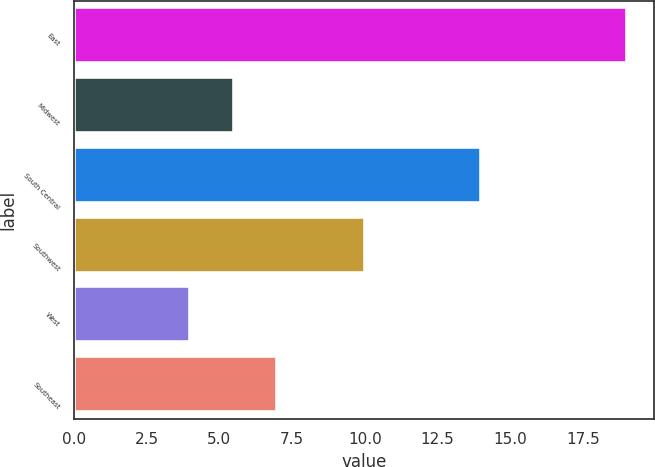<chart> <loc_0><loc_0><loc_500><loc_500><bar_chart><fcel>East<fcel>Midwest<fcel>South Central<fcel>Southwest<fcel>West<fcel>Southeast<nl><fcel>19<fcel>5.5<fcel>14<fcel>10<fcel>4<fcel>7<nl></chart> 